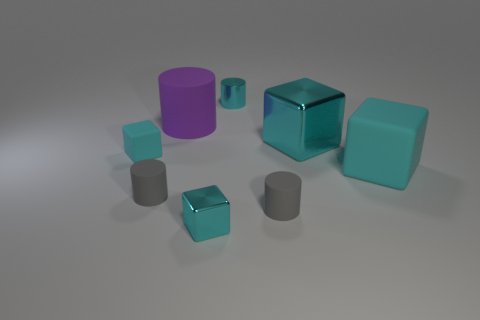Subtract 1 cylinders. How many cylinders are left? 3 Add 1 small yellow rubber things. How many objects exist? 9 Subtract all big matte spheres. Subtract all small metal objects. How many objects are left? 6 Add 3 tiny gray things. How many tiny gray things are left? 5 Add 6 gray matte blocks. How many gray matte blocks exist? 6 Subtract 0 green cylinders. How many objects are left? 8 